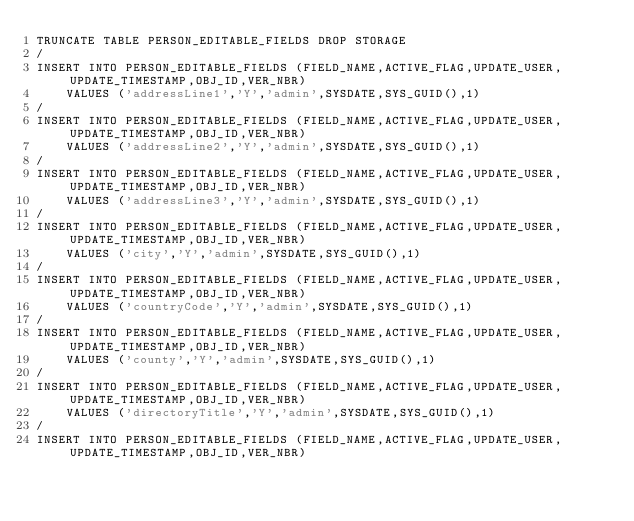Convert code to text. <code><loc_0><loc_0><loc_500><loc_500><_SQL_>TRUNCATE TABLE PERSON_EDITABLE_FIELDS DROP STORAGE
/
INSERT INTO PERSON_EDITABLE_FIELDS (FIELD_NAME,ACTIVE_FLAG,UPDATE_USER,UPDATE_TIMESTAMP,OBJ_ID,VER_NBR) 
    VALUES ('addressLine1','Y','admin',SYSDATE,SYS_GUID(),1)
/
INSERT INTO PERSON_EDITABLE_FIELDS (FIELD_NAME,ACTIVE_FLAG,UPDATE_USER,UPDATE_TIMESTAMP,OBJ_ID,VER_NBR) 
    VALUES ('addressLine2','Y','admin',SYSDATE,SYS_GUID(),1)
/
INSERT INTO PERSON_EDITABLE_FIELDS (FIELD_NAME,ACTIVE_FLAG,UPDATE_USER,UPDATE_TIMESTAMP,OBJ_ID,VER_NBR) 
    VALUES ('addressLine3','Y','admin',SYSDATE,SYS_GUID(),1)
/
INSERT INTO PERSON_EDITABLE_FIELDS (FIELD_NAME,ACTIVE_FLAG,UPDATE_USER,UPDATE_TIMESTAMP,OBJ_ID,VER_NBR) 
    VALUES ('city','Y','admin',SYSDATE,SYS_GUID(),1)
/
INSERT INTO PERSON_EDITABLE_FIELDS (FIELD_NAME,ACTIVE_FLAG,UPDATE_USER,UPDATE_TIMESTAMP,OBJ_ID,VER_NBR) 
    VALUES ('countryCode','Y','admin',SYSDATE,SYS_GUID(),1)
/
INSERT INTO PERSON_EDITABLE_FIELDS (FIELD_NAME,ACTIVE_FLAG,UPDATE_USER,UPDATE_TIMESTAMP,OBJ_ID,VER_NBR) 
    VALUES ('county','Y','admin',SYSDATE,SYS_GUID(),1)
/
INSERT INTO PERSON_EDITABLE_FIELDS (FIELD_NAME,ACTIVE_FLAG,UPDATE_USER,UPDATE_TIMESTAMP,OBJ_ID,VER_NBR) 
    VALUES ('directoryTitle','Y','admin',SYSDATE,SYS_GUID(),1)
/
INSERT INTO PERSON_EDITABLE_FIELDS (FIELD_NAME,ACTIVE_FLAG,UPDATE_USER,UPDATE_TIMESTAMP,OBJ_ID,VER_NBR) </code> 